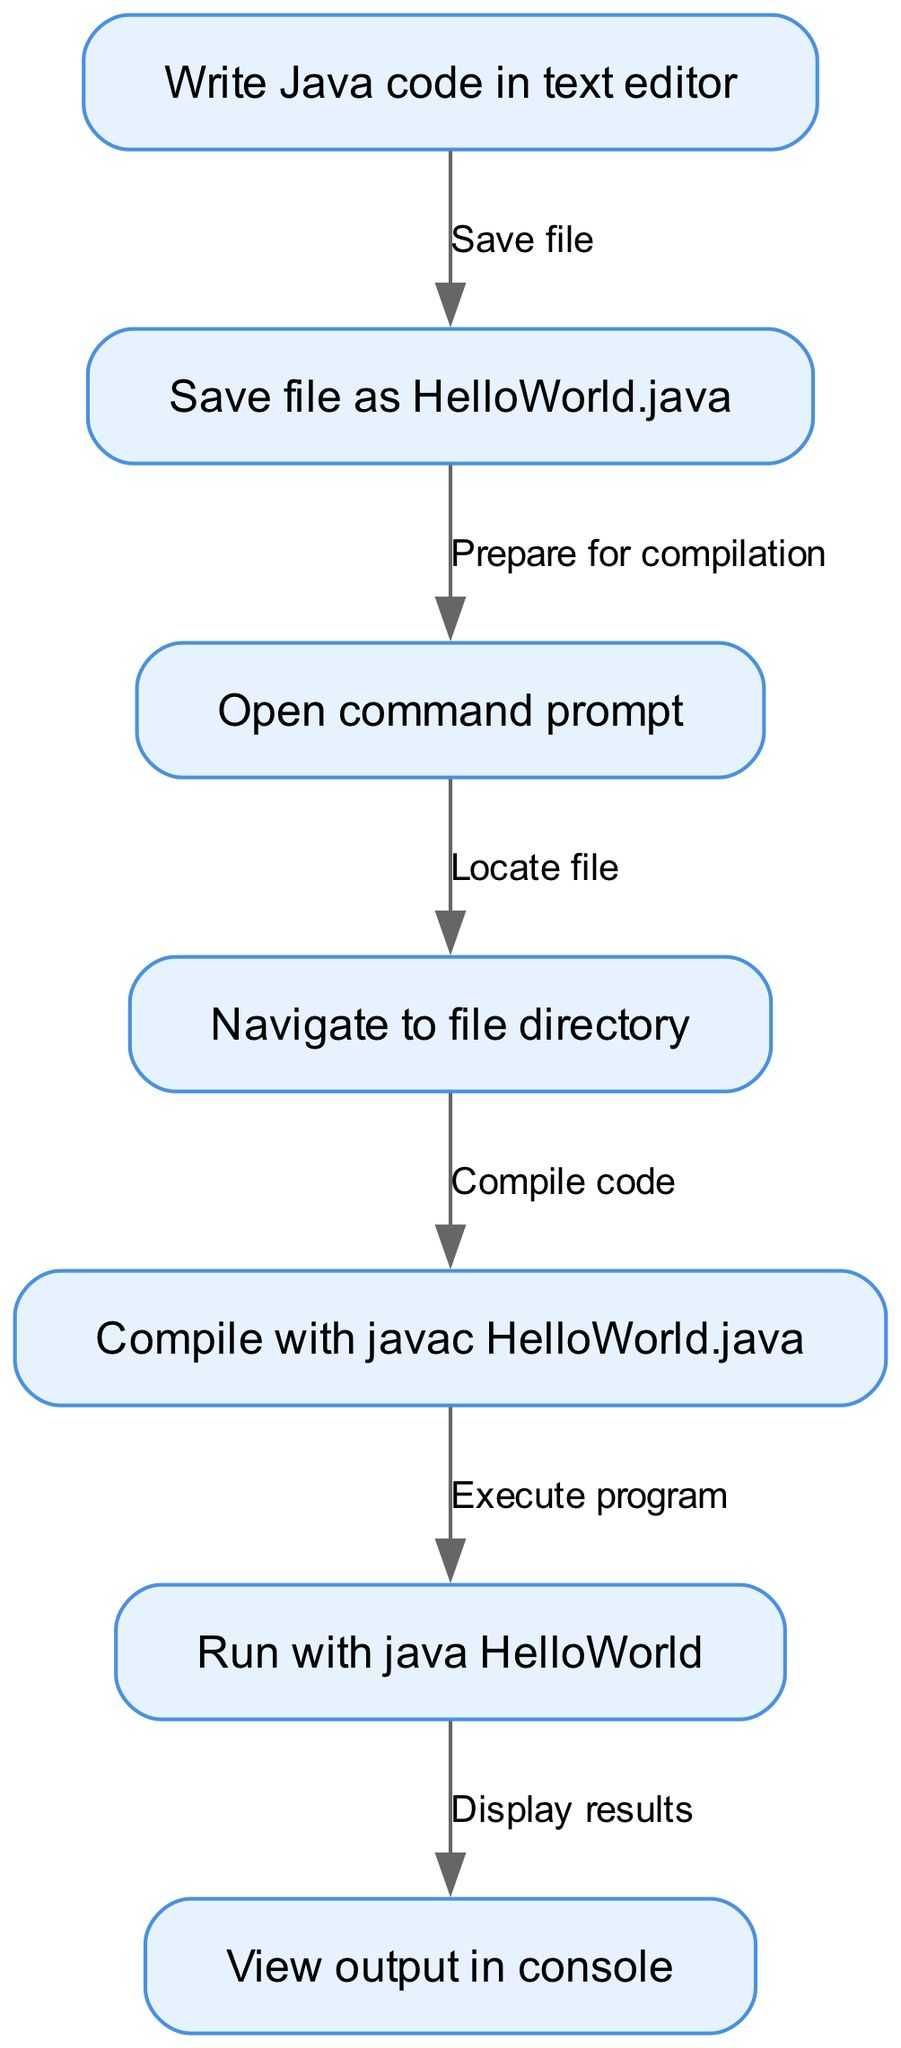What is the first step in the process? The first step, as indicated in the diagram, is to write Java code in a text editor. This is shown as the starting node in the flow.
Answer: Write Java code in text editor How many nodes are there in the diagram? The total number of nodes includes each distinct step outlined in the process. Counting them from the diagram, we find there are 7 nodes.
Answer: 7 What is the command used to compile the Java file? The diagram specifies that the command to compile the file is "javac HelloWorld.java". This is shown as the output of the compilation step node.
Answer: javac HelloWorld.java Which step comes immediately after saving the file? After saving the file as "HelloWorld.java", the next step is to open the command prompt, which is directly linked as the subsequent node.
Answer: Open command prompt What is the relationship between compiling the code and executing the program? The relationship indicates that after compiling the code, which is the compile step, you then proceed to execute the program, as shown by the directed flow from the compile node to the execute node.
Answer: Execute program What is viewed in the console after running the program? Upon running the program, the output displayed in the console will provide the results of the execution, as indicated in the final step of the diagram.
Answer: View output in console What step involves navigating to the file directory? The step of navigating to the file directory follows the command prompt opening and is illustrated in the diagram as the fourth node in the workflow.
Answer: Navigate to file directory How many edges are in the diagram? The diagram displays connections between steps, represented as edges. There are a total of 6 edges connecting all the nodes together in the process.
Answer: 6 